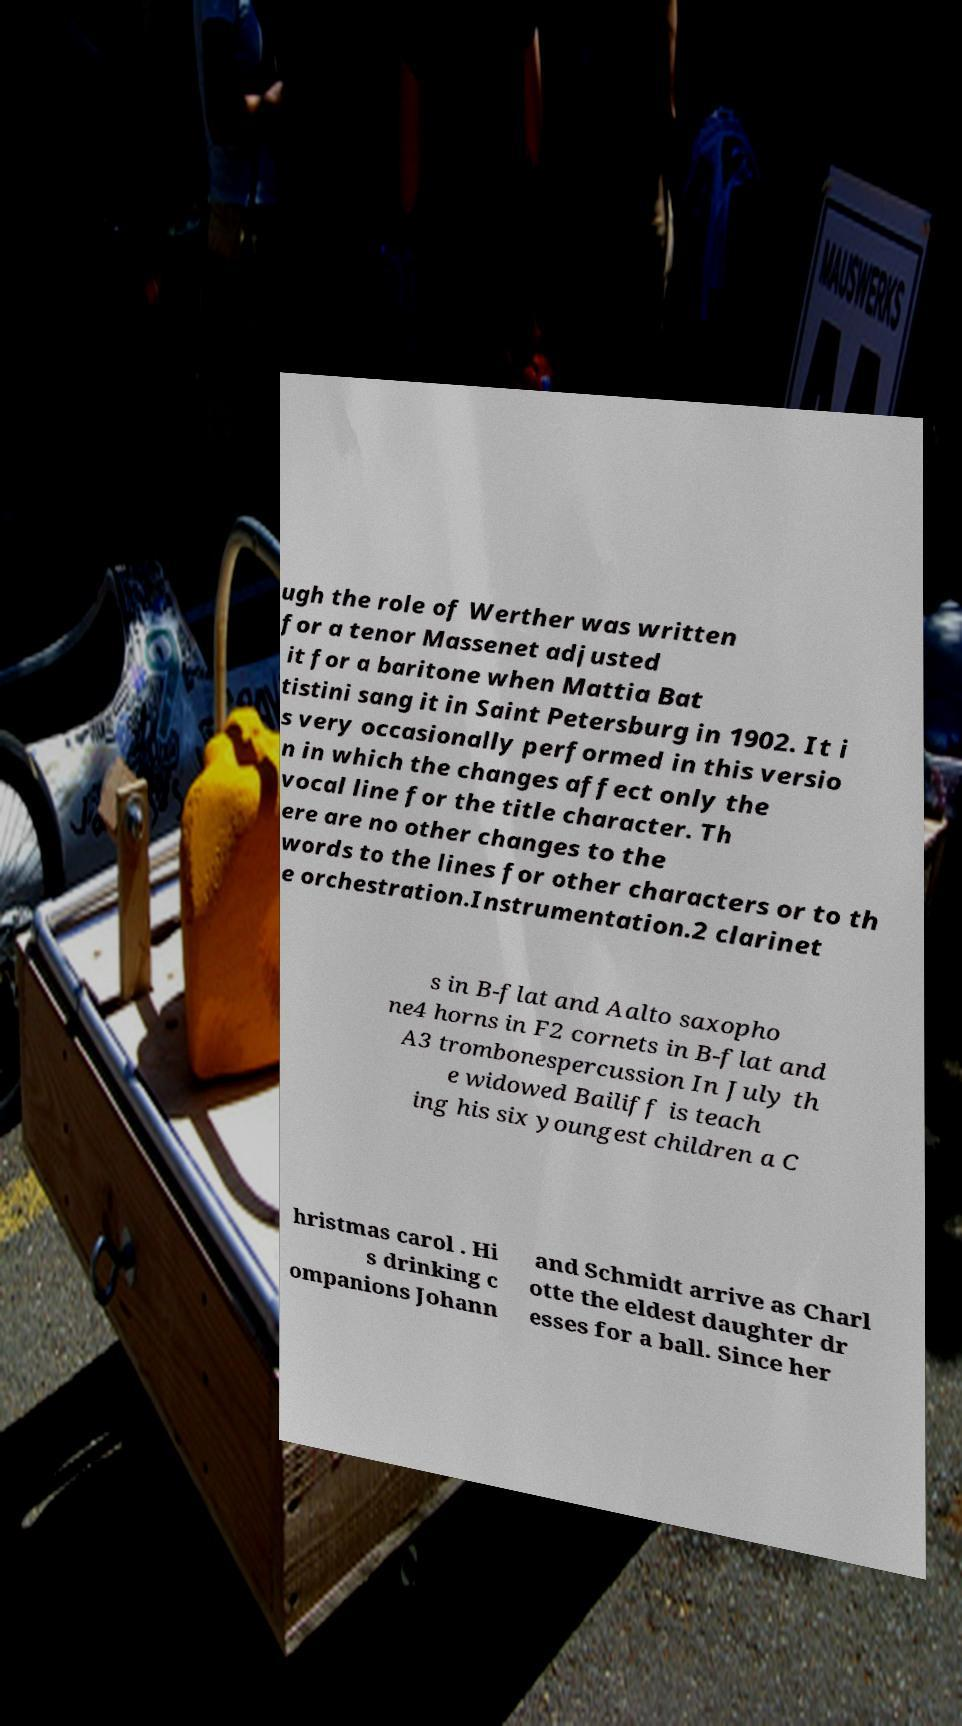Could you assist in decoding the text presented in this image and type it out clearly? ugh the role of Werther was written for a tenor Massenet adjusted it for a baritone when Mattia Bat tistini sang it in Saint Petersburg in 1902. It i s very occasionally performed in this versio n in which the changes affect only the vocal line for the title character. Th ere are no other changes to the words to the lines for other characters or to th e orchestration.Instrumentation.2 clarinet s in B-flat and Aalto saxopho ne4 horns in F2 cornets in B-flat and A3 trombonespercussion In July th e widowed Bailiff is teach ing his six youngest children a C hristmas carol . Hi s drinking c ompanions Johann and Schmidt arrive as Charl otte the eldest daughter dr esses for a ball. Since her 